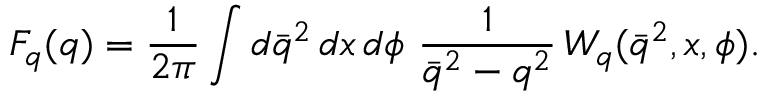<formula> <loc_0><loc_0><loc_500><loc_500>F _ { q } ( q ) = { \frac { 1 } { 2 \pi } } \int d \bar { q } ^ { 2 } \, d x \, d \phi \ { \frac { 1 } { \bar { q } ^ { 2 } - q ^ { 2 } } } \, { W } _ { q } ( \bar { q } ^ { 2 } , x , \phi ) .</formula> 